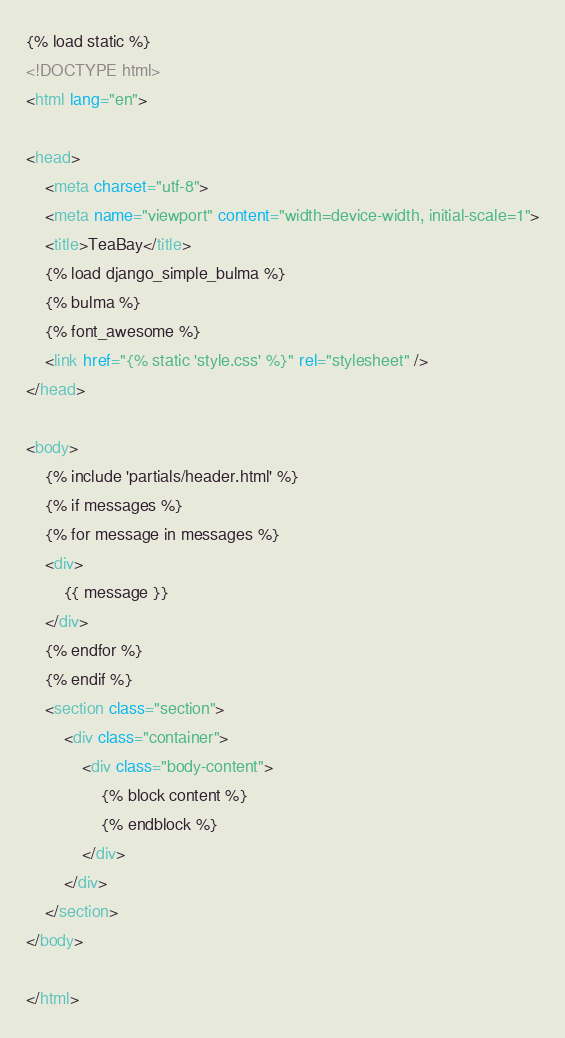<code> <loc_0><loc_0><loc_500><loc_500><_HTML_>{% load static %}
<!DOCTYPE html>
<html lang="en">

<head>
    <meta charset="utf-8">
    <meta name="viewport" content="width=device-width, initial-scale=1">
    <title>TeaBay</title>
    {% load django_simple_bulma %}
    {% bulma %}
    {% font_awesome %}
    <link href="{% static 'style.css' %}" rel="stylesheet" />
</head>

<body>
    {% include 'partials/header.html' %}
    {% if messages %}
    {% for message in messages %}
    <div>
        {{ message }}
    </div>
    {% endfor %}
    {% endif %}
    <section class="section">
        <div class="container">
            <div class="body-content">
                {% block content %}
                {% endblock %}
            </div>
        </div>
    </section>
</body>

</html>
</code> 